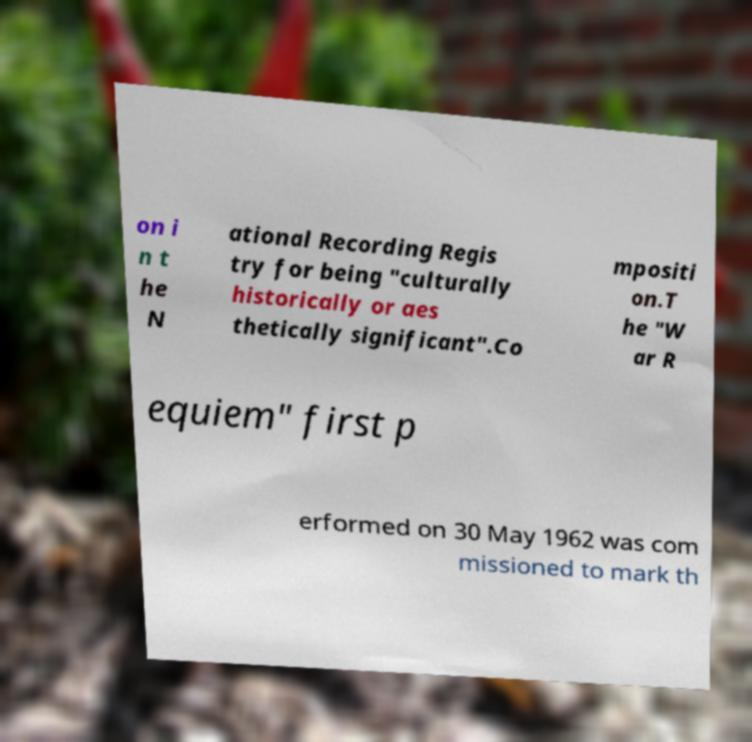Please identify and transcribe the text found in this image. on i n t he N ational Recording Regis try for being "culturally historically or aes thetically significant".Co mpositi on.T he "W ar R equiem" first p erformed on 30 May 1962 was com missioned to mark th 